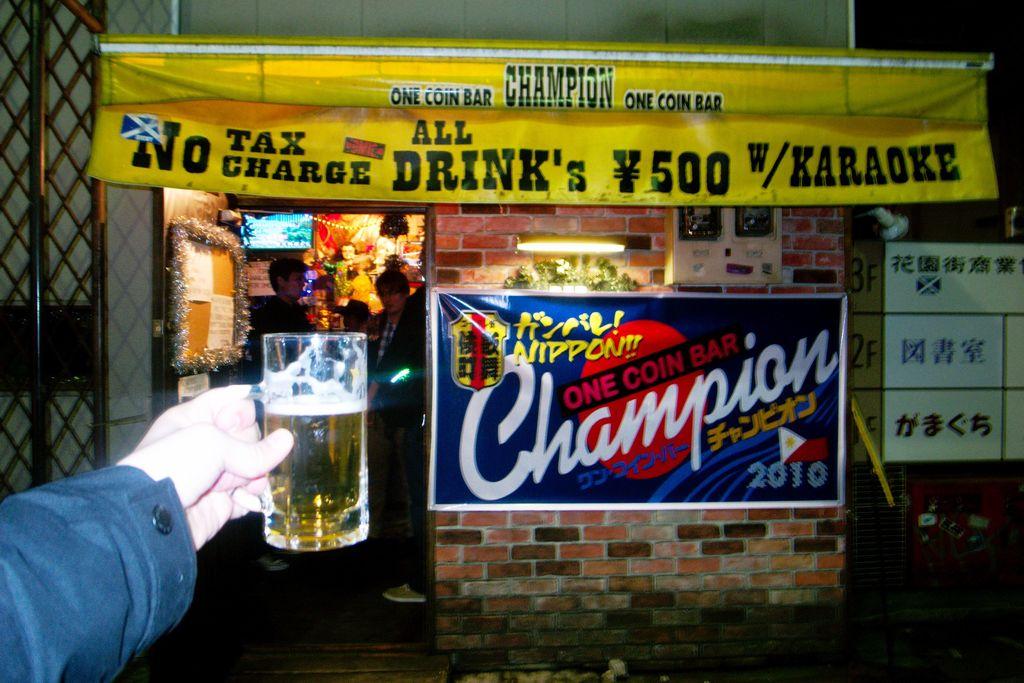What does it offer as far as singing?
Your answer should be compact. Karaoke. 